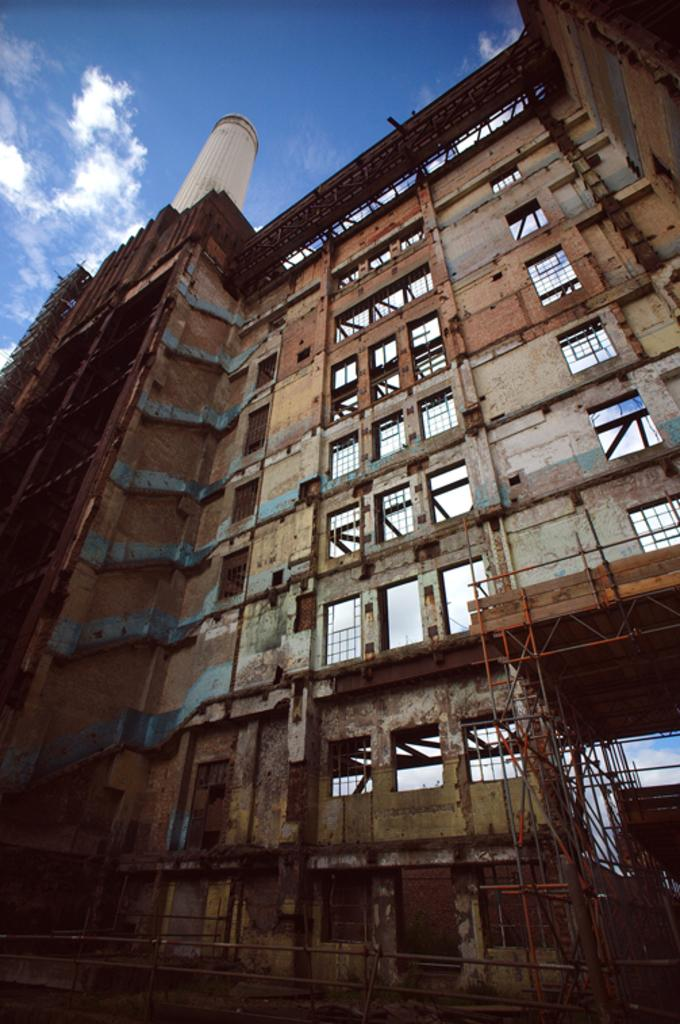What type of structure is present in the image? There is a building in the image. What other objects can be seen in the image? There are rods visible in the image. Can you describe the tower in the image? The tower in the image is white in color. What is visible in the background of the image? The sky is visible in the image. How would you describe the color of the sky in the image? The sky has a combination of white and blue colors in the image. What type of produce is being harvested in the image? There is no produce or harvesting activity present in the image. Can you see the head of the person operating the airplane in the image? There is no airplane or person operating it present in the image. 